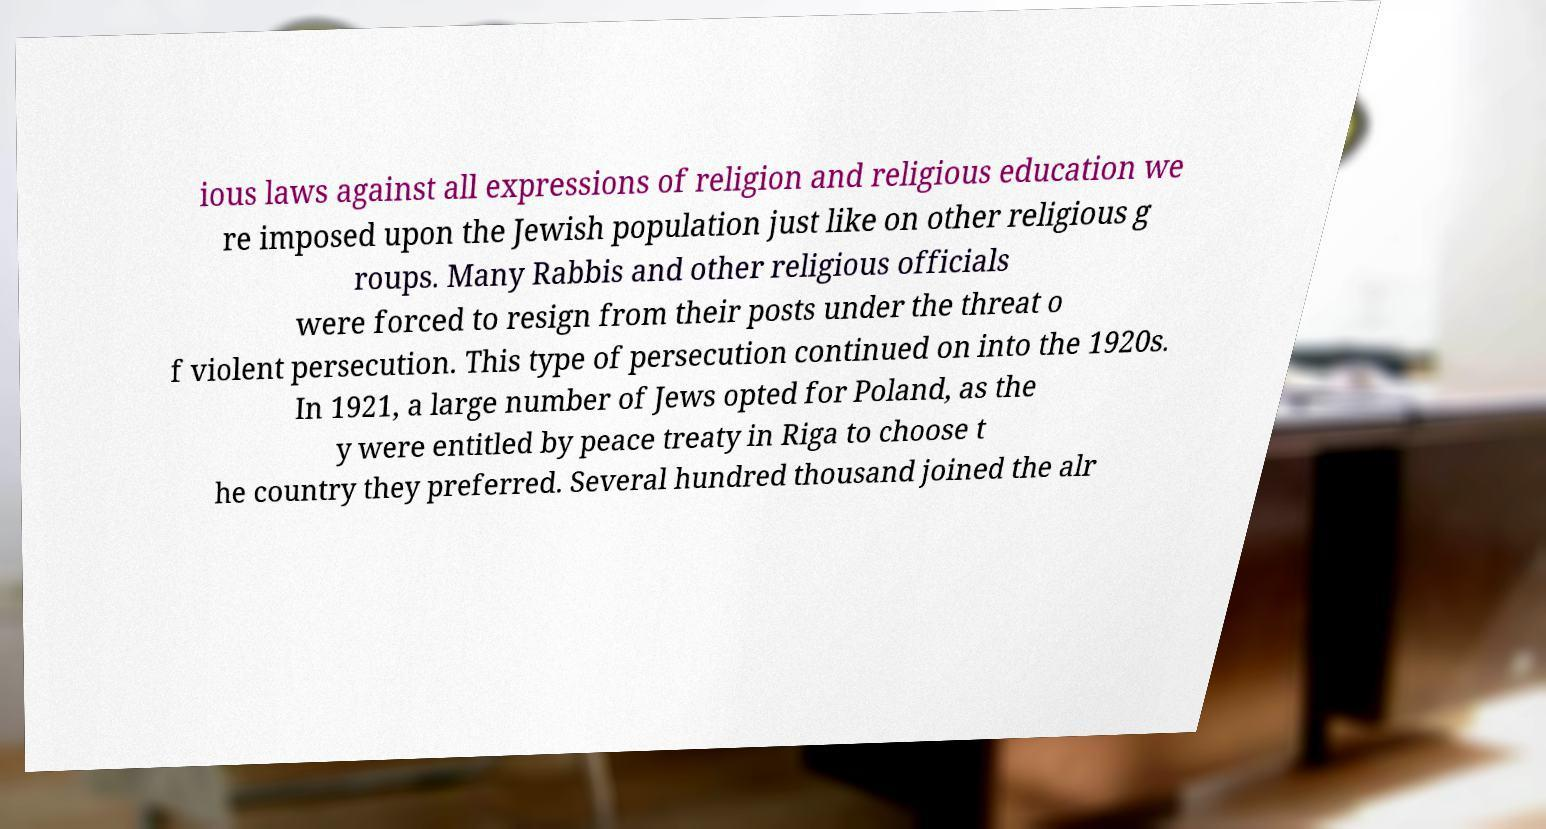Can you read and provide the text displayed in the image?This photo seems to have some interesting text. Can you extract and type it out for me? ious laws against all expressions of religion and religious education we re imposed upon the Jewish population just like on other religious g roups. Many Rabbis and other religious officials were forced to resign from their posts under the threat o f violent persecution. This type of persecution continued on into the 1920s. In 1921, a large number of Jews opted for Poland, as the y were entitled by peace treaty in Riga to choose t he country they preferred. Several hundred thousand joined the alr 